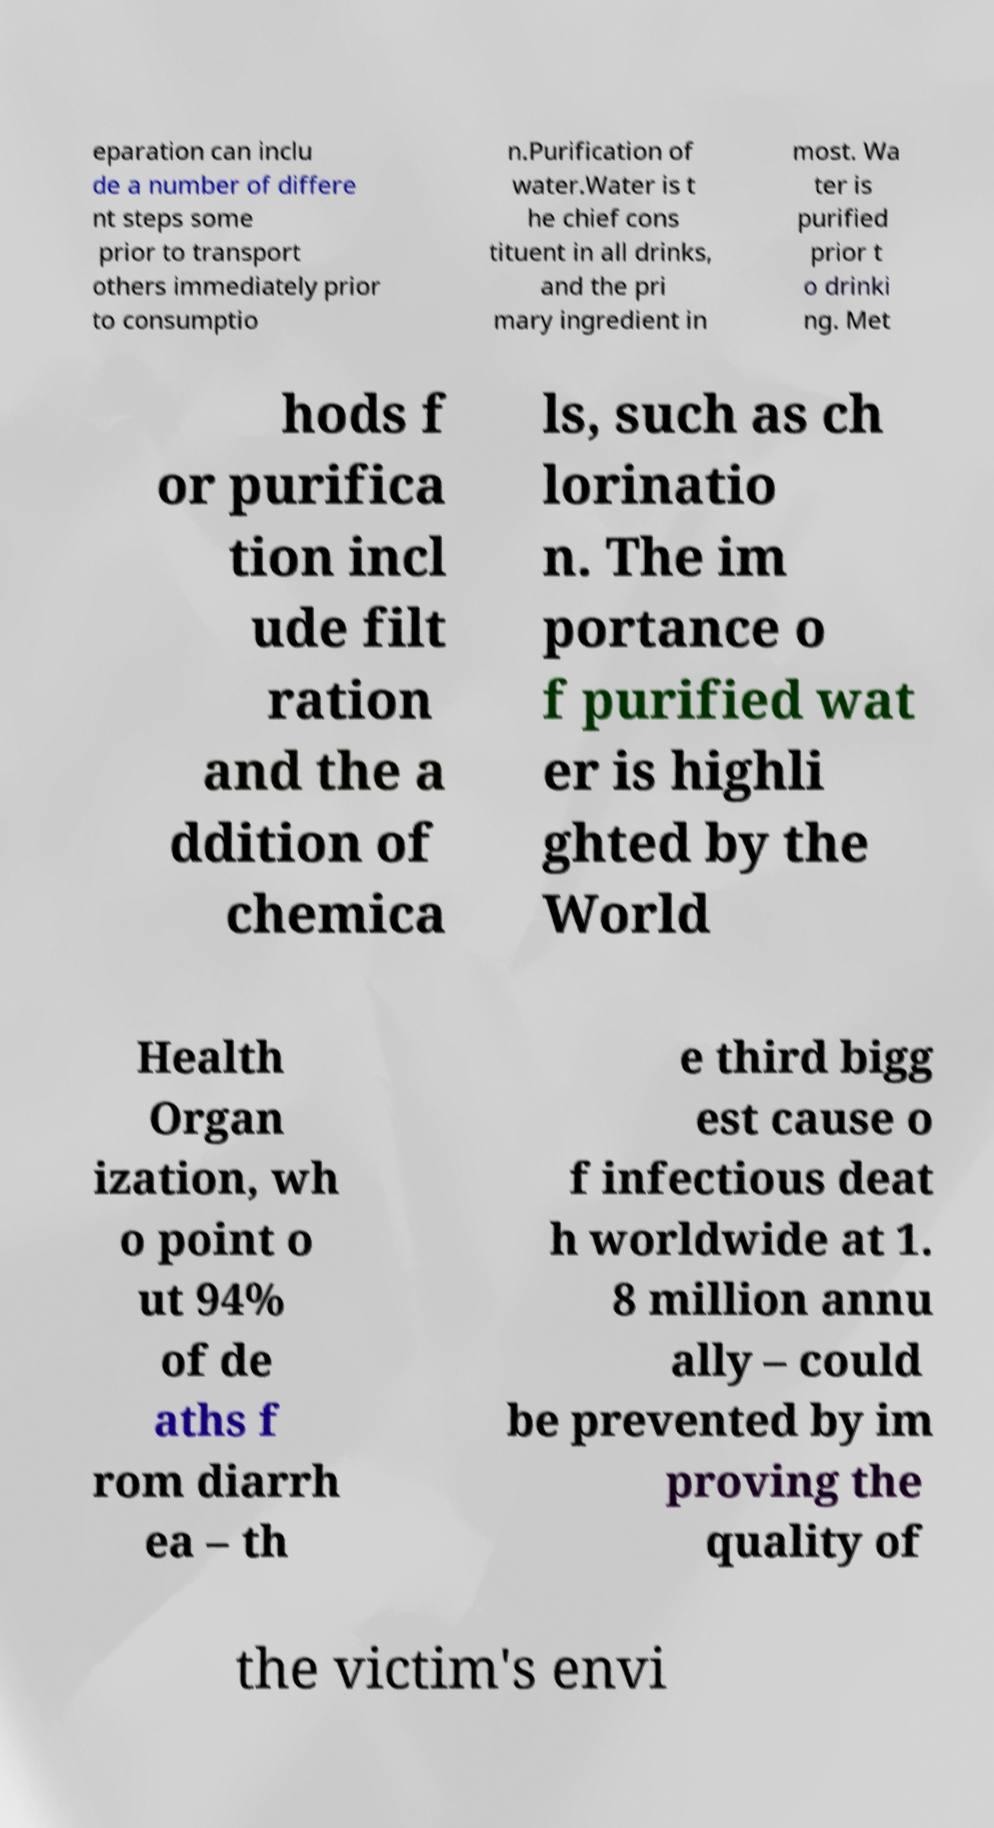Please identify and transcribe the text found in this image. eparation can inclu de a number of differe nt steps some prior to transport others immediately prior to consumptio n.Purification of water.Water is t he chief cons tituent in all drinks, and the pri mary ingredient in most. Wa ter is purified prior t o drinki ng. Met hods f or purifica tion incl ude filt ration and the a ddition of chemica ls, such as ch lorinatio n. The im portance o f purified wat er is highli ghted by the World Health Organ ization, wh o point o ut 94% of de aths f rom diarrh ea – th e third bigg est cause o f infectious deat h worldwide at 1. 8 million annu ally – could be prevented by im proving the quality of the victim's envi 